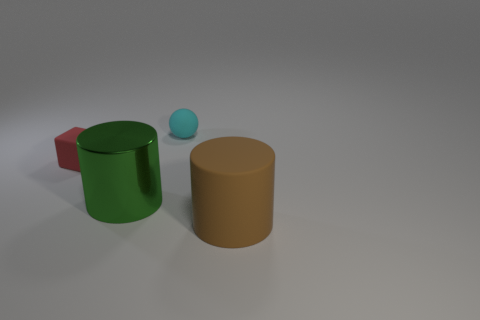Add 4 tiny rubber blocks. How many objects exist? 8 Subtract all spheres. How many objects are left? 3 Subtract 0 gray cubes. How many objects are left? 4 Subtract all blue rubber cylinders. Subtract all balls. How many objects are left? 3 Add 1 small spheres. How many small spheres are left? 2 Add 4 green metal things. How many green metal things exist? 5 